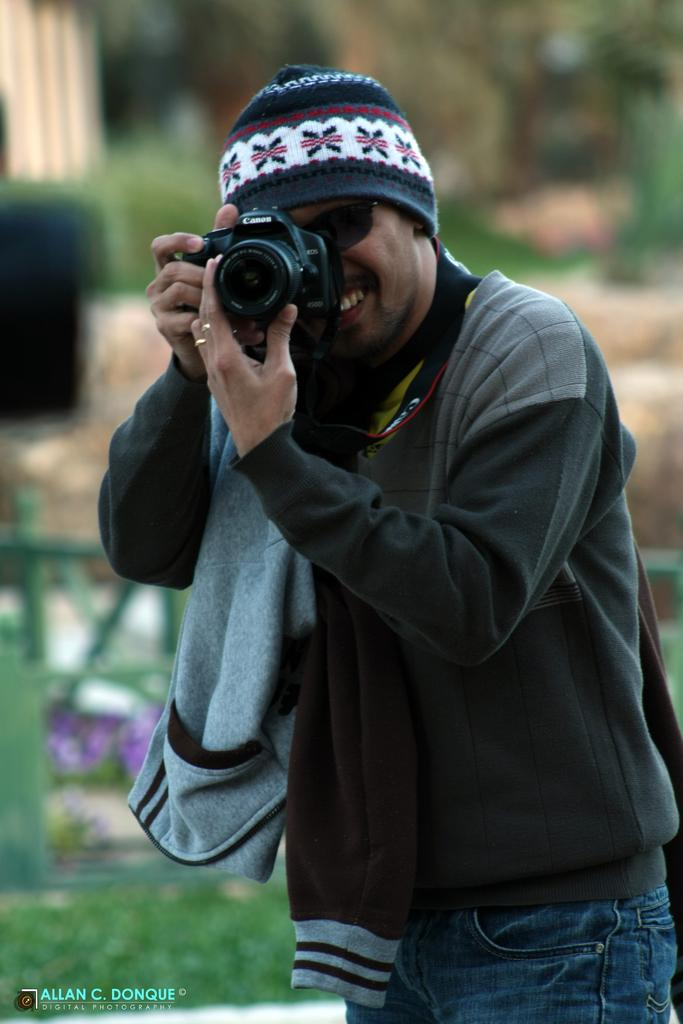What can be observed about the background of the image? The background of the image is blurry. Who is present in the image? There is a man in the image. What is the man wearing on his face? The man is wearing goggles. What is the man wearing on his head? The man is wearing a cap. What is the man holding in his hands? The man is holding a camera in his hands. What is the man doing with the camera? The man is recording with the camera. What type of chalk is the man using to write on the wall in the image? There is no chalk or wall present in the image; the man is holding a camera and wearing goggles and a cap. What kind of teeth can be seen in the image? There are no teeth visible in the image, as it features a man holding a camera and wearing goggles and a cap. 